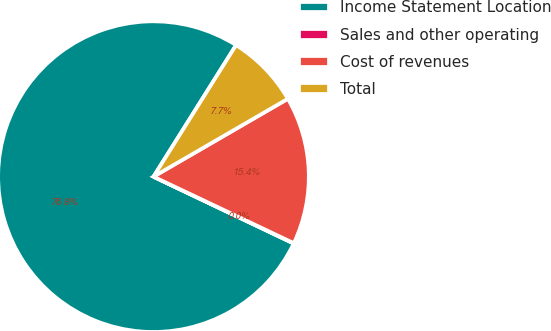Convert chart. <chart><loc_0><loc_0><loc_500><loc_500><pie_chart><fcel>Income Statement Location<fcel>Sales and other operating<fcel>Cost of revenues<fcel>Total<nl><fcel>76.84%<fcel>0.04%<fcel>15.4%<fcel>7.72%<nl></chart> 